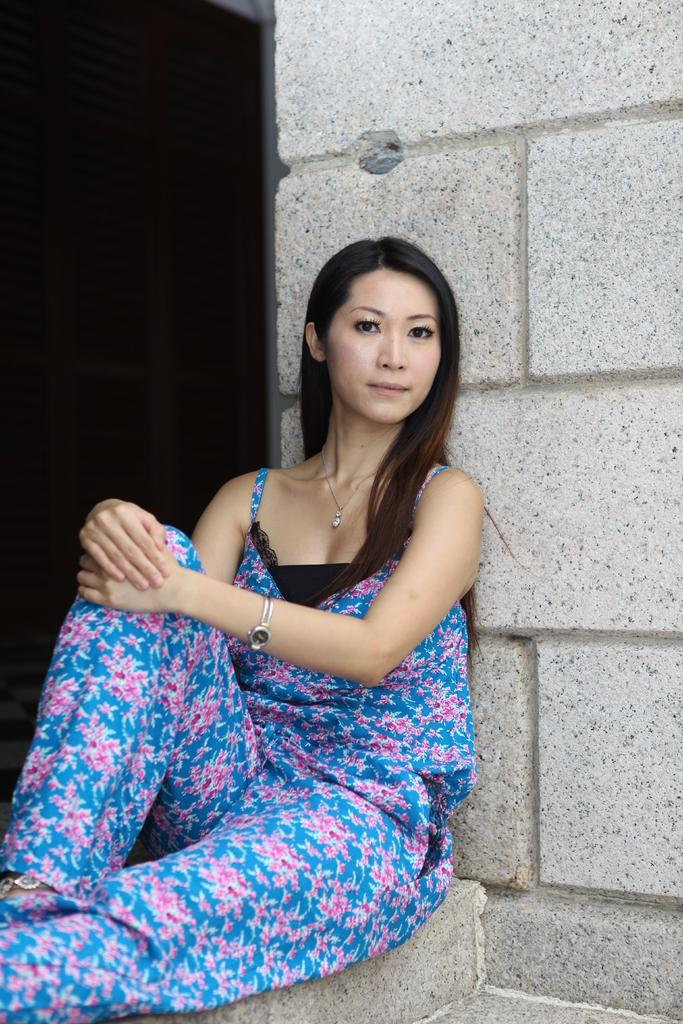Who is present in the image? There is a woman in the image. What is the woman doing in the image? The woman is sitting on a step. What can be seen behind the woman in the image? There is a wall visible behind the woman. How many bulbs are hanging from the shelf in the image? There are no bulbs or shelves present in the image. 